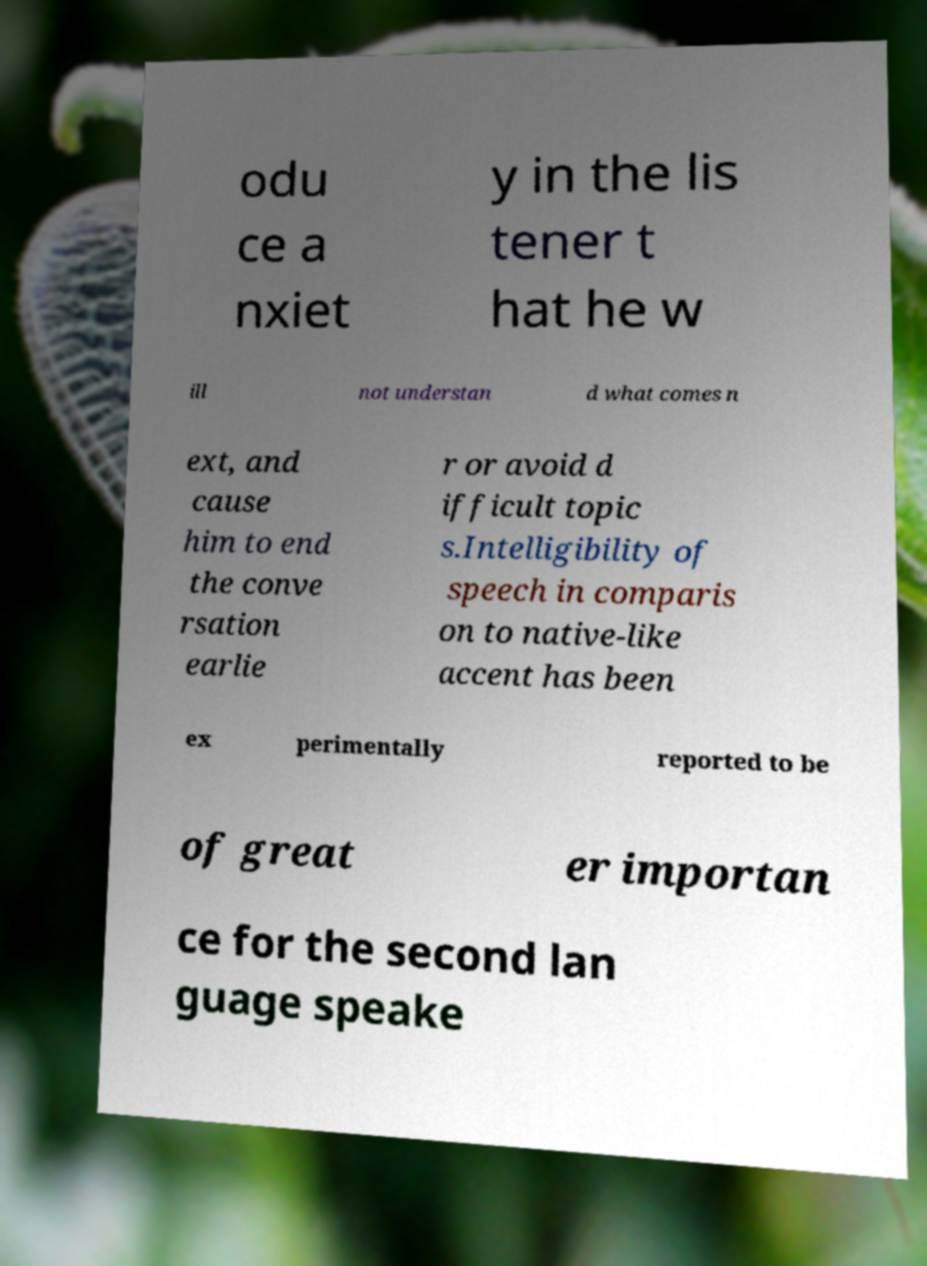I need the written content from this picture converted into text. Can you do that? odu ce a nxiet y in the lis tener t hat he w ill not understan d what comes n ext, and cause him to end the conve rsation earlie r or avoid d ifficult topic s.Intelligibility of speech in comparis on to native-like accent has been ex perimentally reported to be of great er importan ce for the second lan guage speake 